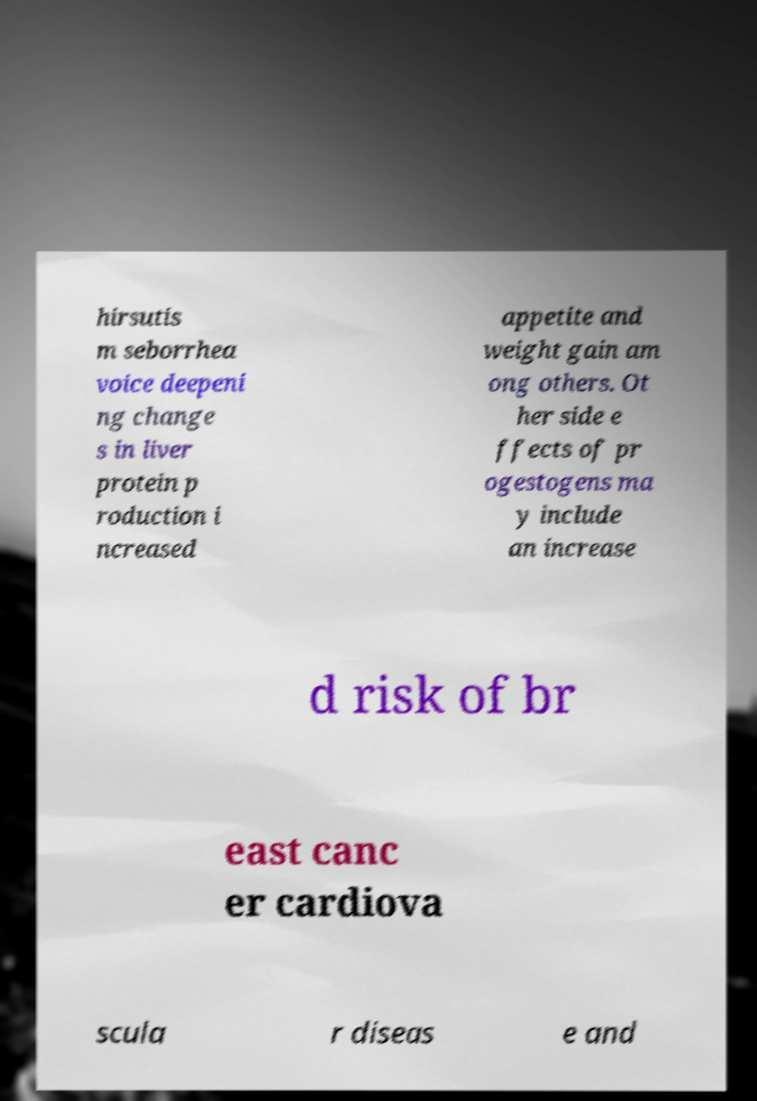What messages or text are displayed in this image? I need them in a readable, typed format. hirsutis m seborrhea voice deepeni ng change s in liver protein p roduction i ncreased appetite and weight gain am ong others. Ot her side e ffects of pr ogestogens ma y include an increase d risk of br east canc er cardiova scula r diseas e and 